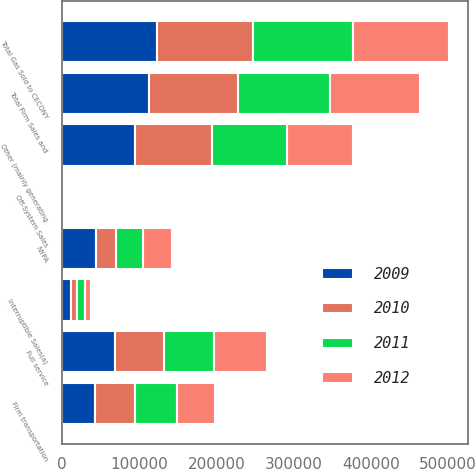Convert chart to OTSL. <chart><loc_0><loc_0><loc_500><loc_500><stacked_bar_chart><ecel><fcel>Full service<fcel>Firm transportation<fcel>Total Firm Sales and<fcel>Interruptible Sales(a)<fcel>Total Gas Sold to CECONY<fcel>NYPA<fcel>Other (mainly generating<fcel>Off-System Sales<nl><fcel>2009<fcel>68943<fcel>43245<fcel>112188<fcel>11220<fcel>123408<fcel>44694<fcel>94086<fcel>154<nl><fcel>2012<fcel>67994<fcel>48671<fcel>116665<fcel>8225<fcel>124890<fcel>37764<fcel>86454<fcel>1<nl><fcel>2010<fcel>63592<fcel>51859<fcel>115451<fcel>8521<fcel>123972<fcel>24890<fcel>99666<fcel>7<nl><fcel>2011<fcel>64696<fcel>54291<fcel>118987<fcel>10035<fcel>129022<fcel>34893<fcel>97163<fcel>97<nl></chart> 